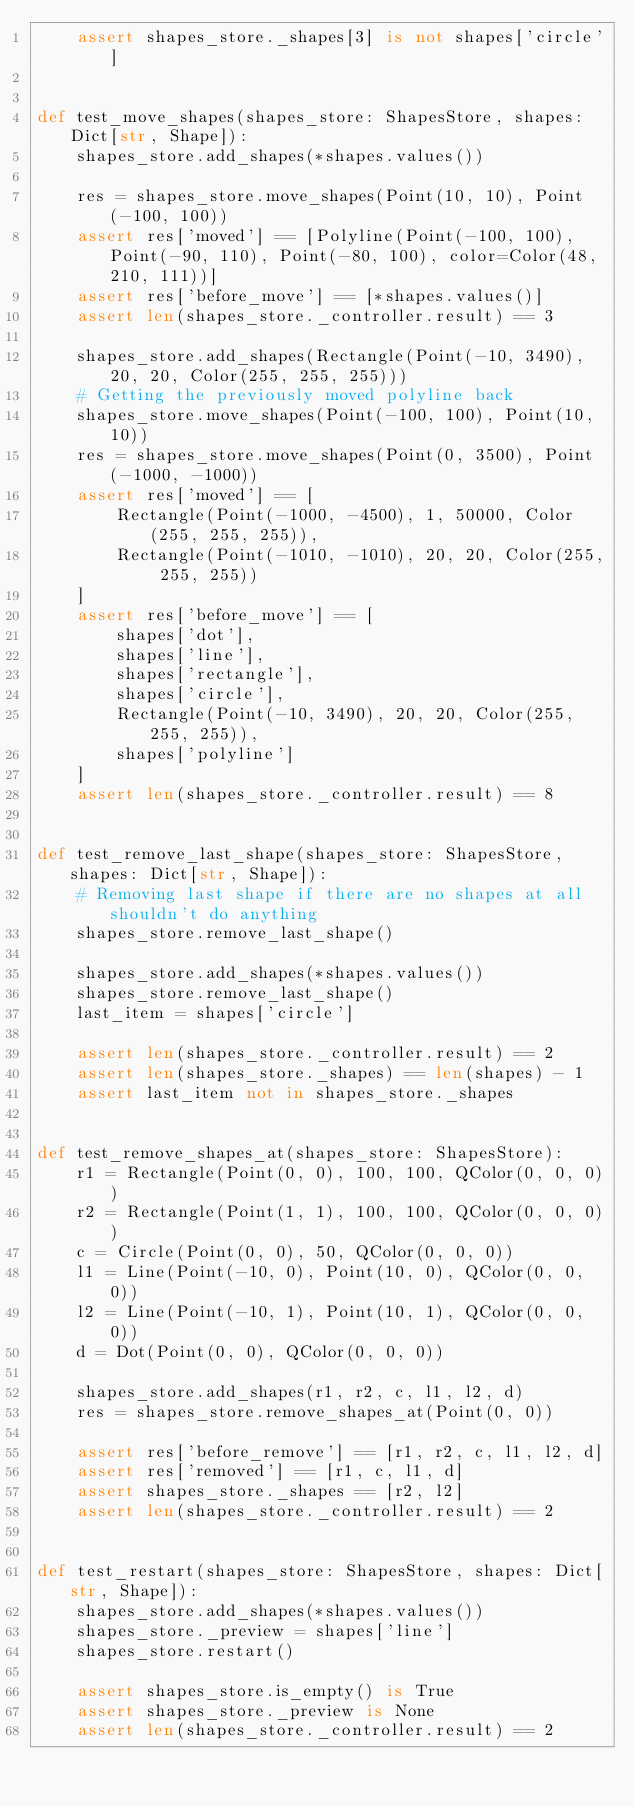<code> <loc_0><loc_0><loc_500><loc_500><_Python_>    assert shapes_store._shapes[3] is not shapes['circle']


def test_move_shapes(shapes_store: ShapesStore, shapes: Dict[str, Shape]):
    shapes_store.add_shapes(*shapes.values())

    res = shapes_store.move_shapes(Point(10, 10), Point(-100, 100))
    assert res['moved'] == [Polyline(Point(-100, 100), Point(-90, 110), Point(-80, 100), color=Color(48, 210, 111))]
    assert res['before_move'] == [*shapes.values()]
    assert len(shapes_store._controller.result) == 3

    shapes_store.add_shapes(Rectangle(Point(-10, 3490), 20, 20, Color(255, 255, 255)))
    # Getting the previously moved polyline back
    shapes_store.move_shapes(Point(-100, 100), Point(10, 10))
    res = shapes_store.move_shapes(Point(0, 3500), Point(-1000, -1000))
    assert res['moved'] == [
        Rectangle(Point(-1000, -4500), 1, 50000, Color(255, 255, 255)),
        Rectangle(Point(-1010, -1010), 20, 20, Color(255, 255, 255))
    ]
    assert res['before_move'] == [
        shapes['dot'],
        shapes['line'],
        shapes['rectangle'],
        shapes['circle'],
        Rectangle(Point(-10, 3490), 20, 20, Color(255, 255, 255)),
        shapes['polyline']
    ]
    assert len(shapes_store._controller.result) == 8


def test_remove_last_shape(shapes_store: ShapesStore, shapes: Dict[str, Shape]):
    # Removing last shape if there are no shapes at all shouldn't do anything
    shapes_store.remove_last_shape()

    shapes_store.add_shapes(*shapes.values())
    shapes_store.remove_last_shape()
    last_item = shapes['circle']

    assert len(shapes_store._controller.result) == 2
    assert len(shapes_store._shapes) == len(shapes) - 1
    assert last_item not in shapes_store._shapes


def test_remove_shapes_at(shapes_store: ShapesStore):
    r1 = Rectangle(Point(0, 0), 100, 100, QColor(0, 0, 0))
    r2 = Rectangle(Point(1, 1), 100, 100, QColor(0, 0, 0))
    c = Circle(Point(0, 0), 50, QColor(0, 0, 0))
    l1 = Line(Point(-10, 0), Point(10, 0), QColor(0, 0, 0))
    l2 = Line(Point(-10, 1), Point(10, 1), QColor(0, 0, 0))
    d = Dot(Point(0, 0), QColor(0, 0, 0))

    shapes_store.add_shapes(r1, r2, c, l1, l2, d)
    res = shapes_store.remove_shapes_at(Point(0, 0))

    assert res['before_remove'] == [r1, r2, c, l1, l2, d]
    assert res['removed'] == [r1, c, l1, d]
    assert shapes_store._shapes == [r2, l2]
    assert len(shapes_store._controller.result) == 2


def test_restart(shapes_store: ShapesStore, shapes: Dict[str, Shape]):
    shapes_store.add_shapes(*shapes.values())
    shapes_store._preview = shapes['line']
    shapes_store.restart()

    assert shapes_store.is_empty() is True
    assert shapes_store._preview is None
    assert len(shapes_store._controller.result) == 2
</code> 